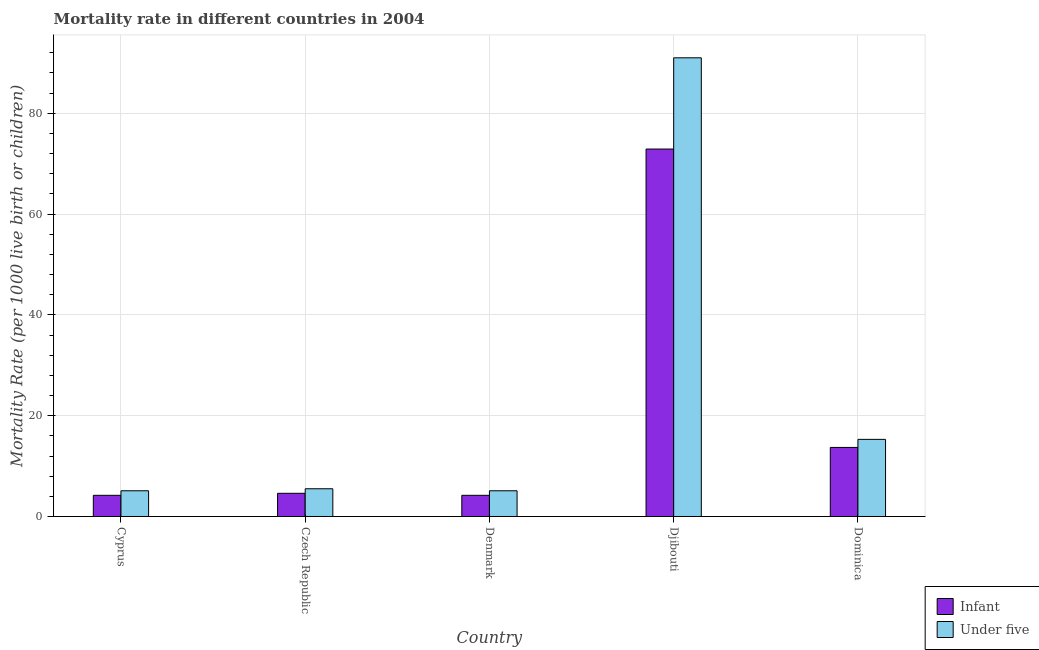Are the number of bars per tick equal to the number of legend labels?
Provide a succinct answer. Yes. Are the number of bars on each tick of the X-axis equal?
Ensure brevity in your answer.  Yes. What is the label of the 2nd group of bars from the left?
Provide a short and direct response. Czech Republic. What is the infant mortality rate in Czech Republic?
Provide a succinct answer. 4.6. Across all countries, what is the maximum under-5 mortality rate?
Offer a terse response. 91. Across all countries, what is the minimum infant mortality rate?
Your response must be concise. 4.2. In which country was the under-5 mortality rate maximum?
Offer a terse response. Djibouti. In which country was the under-5 mortality rate minimum?
Provide a succinct answer. Cyprus. What is the total under-5 mortality rate in the graph?
Provide a short and direct response. 122. What is the difference between the infant mortality rate in Denmark and that in Djibouti?
Keep it short and to the point. -68.7. What is the difference between the infant mortality rate in Cyprus and the under-5 mortality rate in Dominica?
Your answer should be very brief. -11.1. What is the average infant mortality rate per country?
Your answer should be compact. 19.92. What is the difference between the infant mortality rate and under-5 mortality rate in Dominica?
Your answer should be compact. -1.6. In how many countries, is the infant mortality rate greater than 8 ?
Offer a terse response. 2. What is the ratio of the infant mortality rate in Cyprus to that in Czech Republic?
Give a very brief answer. 0.91. Is the infant mortality rate in Czech Republic less than that in Djibouti?
Provide a succinct answer. Yes. Is the difference between the under-5 mortality rate in Czech Republic and Djibouti greater than the difference between the infant mortality rate in Czech Republic and Djibouti?
Keep it short and to the point. No. What is the difference between the highest and the second highest under-5 mortality rate?
Give a very brief answer. 75.7. What is the difference between the highest and the lowest under-5 mortality rate?
Make the answer very short. 85.9. In how many countries, is the infant mortality rate greater than the average infant mortality rate taken over all countries?
Keep it short and to the point. 1. Is the sum of the infant mortality rate in Czech Republic and Denmark greater than the maximum under-5 mortality rate across all countries?
Ensure brevity in your answer.  No. What does the 2nd bar from the left in Cyprus represents?
Provide a short and direct response. Under five. What does the 1st bar from the right in Djibouti represents?
Ensure brevity in your answer.  Under five. Are all the bars in the graph horizontal?
Your answer should be very brief. No. How many countries are there in the graph?
Keep it short and to the point. 5. What is the difference between two consecutive major ticks on the Y-axis?
Make the answer very short. 20. Are the values on the major ticks of Y-axis written in scientific E-notation?
Make the answer very short. No. Does the graph contain any zero values?
Make the answer very short. No. How many legend labels are there?
Give a very brief answer. 2. What is the title of the graph?
Make the answer very short. Mortality rate in different countries in 2004. What is the label or title of the X-axis?
Provide a succinct answer. Country. What is the label or title of the Y-axis?
Give a very brief answer. Mortality Rate (per 1000 live birth or children). What is the Mortality Rate (per 1000 live birth or children) of Under five in Cyprus?
Your answer should be very brief. 5.1. What is the Mortality Rate (per 1000 live birth or children) in Under five in Denmark?
Your answer should be compact. 5.1. What is the Mortality Rate (per 1000 live birth or children) of Infant in Djibouti?
Offer a very short reply. 72.9. What is the Mortality Rate (per 1000 live birth or children) in Under five in Djibouti?
Make the answer very short. 91. What is the Mortality Rate (per 1000 live birth or children) in Under five in Dominica?
Offer a very short reply. 15.3. Across all countries, what is the maximum Mortality Rate (per 1000 live birth or children) of Infant?
Your response must be concise. 72.9. Across all countries, what is the maximum Mortality Rate (per 1000 live birth or children) in Under five?
Provide a succinct answer. 91. Across all countries, what is the minimum Mortality Rate (per 1000 live birth or children) in Infant?
Your response must be concise. 4.2. Across all countries, what is the minimum Mortality Rate (per 1000 live birth or children) in Under five?
Offer a very short reply. 5.1. What is the total Mortality Rate (per 1000 live birth or children) of Infant in the graph?
Provide a succinct answer. 99.6. What is the total Mortality Rate (per 1000 live birth or children) in Under five in the graph?
Provide a succinct answer. 122. What is the difference between the Mortality Rate (per 1000 live birth or children) of Infant in Cyprus and that in Czech Republic?
Your answer should be very brief. -0.4. What is the difference between the Mortality Rate (per 1000 live birth or children) of Infant in Cyprus and that in Denmark?
Your answer should be very brief. 0. What is the difference between the Mortality Rate (per 1000 live birth or children) in Infant in Cyprus and that in Djibouti?
Ensure brevity in your answer.  -68.7. What is the difference between the Mortality Rate (per 1000 live birth or children) in Under five in Cyprus and that in Djibouti?
Provide a succinct answer. -85.9. What is the difference between the Mortality Rate (per 1000 live birth or children) of Infant in Cyprus and that in Dominica?
Provide a short and direct response. -9.5. What is the difference between the Mortality Rate (per 1000 live birth or children) of Under five in Cyprus and that in Dominica?
Offer a terse response. -10.2. What is the difference between the Mortality Rate (per 1000 live birth or children) of Under five in Czech Republic and that in Denmark?
Provide a short and direct response. 0.4. What is the difference between the Mortality Rate (per 1000 live birth or children) in Infant in Czech Republic and that in Djibouti?
Keep it short and to the point. -68.3. What is the difference between the Mortality Rate (per 1000 live birth or children) in Under five in Czech Republic and that in Djibouti?
Your response must be concise. -85.5. What is the difference between the Mortality Rate (per 1000 live birth or children) in Infant in Czech Republic and that in Dominica?
Your answer should be very brief. -9.1. What is the difference between the Mortality Rate (per 1000 live birth or children) of Infant in Denmark and that in Djibouti?
Ensure brevity in your answer.  -68.7. What is the difference between the Mortality Rate (per 1000 live birth or children) in Under five in Denmark and that in Djibouti?
Provide a succinct answer. -85.9. What is the difference between the Mortality Rate (per 1000 live birth or children) in Infant in Denmark and that in Dominica?
Your response must be concise. -9.5. What is the difference between the Mortality Rate (per 1000 live birth or children) in Infant in Djibouti and that in Dominica?
Your answer should be very brief. 59.2. What is the difference between the Mortality Rate (per 1000 live birth or children) of Under five in Djibouti and that in Dominica?
Provide a short and direct response. 75.7. What is the difference between the Mortality Rate (per 1000 live birth or children) in Infant in Cyprus and the Mortality Rate (per 1000 live birth or children) in Under five in Denmark?
Your answer should be very brief. -0.9. What is the difference between the Mortality Rate (per 1000 live birth or children) of Infant in Cyprus and the Mortality Rate (per 1000 live birth or children) of Under five in Djibouti?
Provide a short and direct response. -86.8. What is the difference between the Mortality Rate (per 1000 live birth or children) in Infant in Cyprus and the Mortality Rate (per 1000 live birth or children) in Under five in Dominica?
Ensure brevity in your answer.  -11.1. What is the difference between the Mortality Rate (per 1000 live birth or children) in Infant in Czech Republic and the Mortality Rate (per 1000 live birth or children) in Under five in Djibouti?
Your response must be concise. -86.4. What is the difference between the Mortality Rate (per 1000 live birth or children) in Infant in Czech Republic and the Mortality Rate (per 1000 live birth or children) in Under five in Dominica?
Your answer should be very brief. -10.7. What is the difference between the Mortality Rate (per 1000 live birth or children) of Infant in Denmark and the Mortality Rate (per 1000 live birth or children) of Under five in Djibouti?
Offer a very short reply. -86.8. What is the difference between the Mortality Rate (per 1000 live birth or children) in Infant in Denmark and the Mortality Rate (per 1000 live birth or children) in Under five in Dominica?
Your response must be concise. -11.1. What is the difference between the Mortality Rate (per 1000 live birth or children) in Infant in Djibouti and the Mortality Rate (per 1000 live birth or children) in Under five in Dominica?
Give a very brief answer. 57.6. What is the average Mortality Rate (per 1000 live birth or children) of Infant per country?
Make the answer very short. 19.92. What is the average Mortality Rate (per 1000 live birth or children) of Under five per country?
Offer a very short reply. 24.4. What is the difference between the Mortality Rate (per 1000 live birth or children) of Infant and Mortality Rate (per 1000 live birth or children) of Under five in Djibouti?
Your answer should be very brief. -18.1. What is the difference between the Mortality Rate (per 1000 live birth or children) of Infant and Mortality Rate (per 1000 live birth or children) of Under five in Dominica?
Give a very brief answer. -1.6. What is the ratio of the Mortality Rate (per 1000 live birth or children) of Infant in Cyprus to that in Czech Republic?
Provide a succinct answer. 0.91. What is the ratio of the Mortality Rate (per 1000 live birth or children) in Under five in Cyprus to that in Czech Republic?
Your response must be concise. 0.93. What is the ratio of the Mortality Rate (per 1000 live birth or children) of Infant in Cyprus to that in Denmark?
Provide a short and direct response. 1. What is the ratio of the Mortality Rate (per 1000 live birth or children) of Under five in Cyprus to that in Denmark?
Make the answer very short. 1. What is the ratio of the Mortality Rate (per 1000 live birth or children) of Infant in Cyprus to that in Djibouti?
Your response must be concise. 0.06. What is the ratio of the Mortality Rate (per 1000 live birth or children) in Under five in Cyprus to that in Djibouti?
Your answer should be compact. 0.06. What is the ratio of the Mortality Rate (per 1000 live birth or children) of Infant in Cyprus to that in Dominica?
Offer a very short reply. 0.31. What is the ratio of the Mortality Rate (per 1000 live birth or children) of Under five in Cyprus to that in Dominica?
Offer a very short reply. 0.33. What is the ratio of the Mortality Rate (per 1000 live birth or children) of Infant in Czech Republic to that in Denmark?
Give a very brief answer. 1.1. What is the ratio of the Mortality Rate (per 1000 live birth or children) of Under five in Czech Republic to that in Denmark?
Provide a short and direct response. 1.08. What is the ratio of the Mortality Rate (per 1000 live birth or children) in Infant in Czech Republic to that in Djibouti?
Ensure brevity in your answer.  0.06. What is the ratio of the Mortality Rate (per 1000 live birth or children) of Under five in Czech Republic to that in Djibouti?
Your answer should be compact. 0.06. What is the ratio of the Mortality Rate (per 1000 live birth or children) in Infant in Czech Republic to that in Dominica?
Offer a very short reply. 0.34. What is the ratio of the Mortality Rate (per 1000 live birth or children) in Under five in Czech Republic to that in Dominica?
Offer a terse response. 0.36. What is the ratio of the Mortality Rate (per 1000 live birth or children) of Infant in Denmark to that in Djibouti?
Your response must be concise. 0.06. What is the ratio of the Mortality Rate (per 1000 live birth or children) in Under five in Denmark to that in Djibouti?
Offer a very short reply. 0.06. What is the ratio of the Mortality Rate (per 1000 live birth or children) in Infant in Denmark to that in Dominica?
Provide a succinct answer. 0.31. What is the ratio of the Mortality Rate (per 1000 live birth or children) of Infant in Djibouti to that in Dominica?
Keep it short and to the point. 5.32. What is the ratio of the Mortality Rate (per 1000 live birth or children) in Under five in Djibouti to that in Dominica?
Offer a terse response. 5.95. What is the difference between the highest and the second highest Mortality Rate (per 1000 live birth or children) of Infant?
Give a very brief answer. 59.2. What is the difference between the highest and the second highest Mortality Rate (per 1000 live birth or children) of Under five?
Your response must be concise. 75.7. What is the difference between the highest and the lowest Mortality Rate (per 1000 live birth or children) of Infant?
Keep it short and to the point. 68.7. What is the difference between the highest and the lowest Mortality Rate (per 1000 live birth or children) of Under five?
Your answer should be very brief. 85.9. 